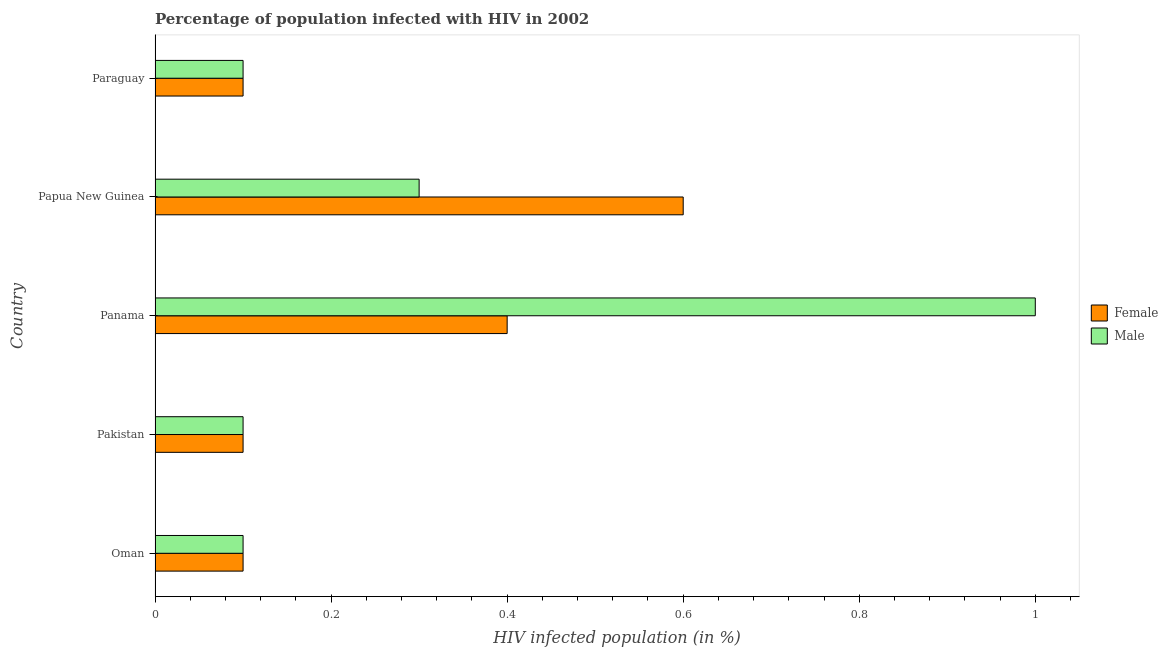What is the label of the 3rd group of bars from the top?
Offer a very short reply. Panama. In how many cases, is the number of bars for a given country not equal to the number of legend labels?
Give a very brief answer. 0. What is the percentage of males who are infected with hiv in Panama?
Offer a terse response. 1. Across all countries, what is the minimum percentage of males who are infected with hiv?
Provide a short and direct response. 0.1. In which country was the percentage of males who are infected with hiv maximum?
Keep it short and to the point. Panama. In which country was the percentage of males who are infected with hiv minimum?
Offer a very short reply. Oman. What is the total percentage of females who are infected with hiv in the graph?
Make the answer very short. 1.3. What is the average percentage of males who are infected with hiv per country?
Give a very brief answer. 0.32. Is the difference between the percentage of females who are infected with hiv in Papua New Guinea and Paraguay greater than the difference between the percentage of males who are infected with hiv in Papua New Guinea and Paraguay?
Provide a short and direct response. Yes. What is the difference between the highest and the second highest percentage of males who are infected with hiv?
Your answer should be very brief. 0.7. Is the sum of the percentage of females who are infected with hiv in Oman and Panama greater than the maximum percentage of males who are infected with hiv across all countries?
Provide a succinct answer. No. How many bars are there?
Offer a very short reply. 10. Are all the bars in the graph horizontal?
Give a very brief answer. Yes. Are the values on the major ticks of X-axis written in scientific E-notation?
Your answer should be very brief. No. How many legend labels are there?
Make the answer very short. 2. What is the title of the graph?
Provide a short and direct response. Percentage of population infected with HIV in 2002. What is the label or title of the X-axis?
Your response must be concise. HIV infected population (in %). What is the HIV infected population (in %) in Male in Oman?
Make the answer very short. 0.1. What is the HIV infected population (in %) in Male in Pakistan?
Make the answer very short. 0.1. What is the HIV infected population (in %) in Female in Panama?
Keep it short and to the point. 0.4. What is the HIV infected population (in %) in Male in Papua New Guinea?
Provide a succinct answer. 0.3. Across all countries, what is the maximum HIV infected population (in %) of Female?
Your response must be concise. 0.6. Across all countries, what is the maximum HIV infected population (in %) in Male?
Offer a very short reply. 1. Across all countries, what is the minimum HIV infected population (in %) in Female?
Your answer should be compact. 0.1. What is the total HIV infected population (in %) in Female in the graph?
Ensure brevity in your answer.  1.3. What is the difference between the HIV infected population (in %) in Male in Oman and that in Pakistan?
Offer a very short reply. 0. What is the difference between the HIV infected population (in %) of Male in Oman and that in Panama?
Your response must be concise. -0.9. What is the difference between the HIV infected population (in %) of Female in Oman and that in Paraguay?
Offer a very short reply. 0. What is the difference between the HIV infected population (in %) of Male in Pakistan and that in Papua New Guinea?
Offer a very short reply. -0.2. What is the difference between the HIV infected population (in %) of Female in Oman and the HIV infected population (in %) of Male in Pakistan?
Ensure brevity in your answer.  0. What is the difference between the HIV infected population (in %) of Female in Oman and the HIV infected population (in %) of Male in Panama?
Give a very brief answer. -0.9. What is the difference between the HIV infected population (in %) of Female in Pakistan and the HIV infected population (in %) of Male in Papua New Guinea?
Ensure brevity in your answer.  -0.2. What is the difference between the HIV infected population (in %) of Female in Papua New Guinea and the HIV infected population (in %) of Male in Paraguay?
Provide a short and direct response. 0.5. What is the average HIV infected population (in %) of Female per country?
Your answer should be compact. 0.26. What is the average HIV infected population (in %) of Male per country?
Your answer should be compact. 0.32. What is the difference between the HIV infected population (in %) of Female and HIV infected population (in %) of Male in Oman?
Ensure brevity in your answer.  0. What is the difference between the HIV infected population (in %) of Female and HIV infected population (in %) of Male in Panama?
Offer a very short reply. -0.6. What is the difference between the HIV infected population (in %) in Female and HIV infected population (in %) in Male in Papua New Guinea?
Offer a terse response. 0.3. What is the ratio of the HIV infected population (in %) in Female in Oman to that in Pakistan?
Your response must be concise. 1. What is the ratio of the HIV infected population (in %) of Female in Oman to that in Panama?
Provide a succinct answer. 0.25. What is the ratio of the HIV infected population (in %) of Male in Oman to that in Panama?
Keep it short and to the point. 0.1. What is the ratio of the HIV infected population (in %) in Female in Oman to that in Paraguay?
Make the answer very short. 1. What is the ratio of the HIV infected population (in %) in Male in Pakistan to that in Panama?
Make the answer very short. 0.1. What is the ratio of the HIV infected population (in %) in Female in Pakistan to that in Papua New Guinea?
Provide a short and direct response. 0.17. What is the ratio of the HIV infected population (in %) of Female in Pakistan to that in Paraguay?
Make the answer very short. 1. What is the ratio of the HIV infected population (in %) in Male in Pakistan to that in Paraguay?
Give a very brief answer. 1. What is the ratio of the HIV infected population (in %) of Male in Panama to that in Papua New Guinea?
Offer a very short reply. 3.33. What is the ratio of the HIV infected population (in %) of Male in Panama to that in Paraguay?
Give a very brief answer. 10. What is the ratio of the HIV infected population (in %) in Male in Papua New Guinea to that in Paraguay?
Your answer should be compact. 3. What is the difference between the highest and the second highest HIV infected population (in %) of Female?
Make the answer very short. 0.2. What is the difference between the highest and the second highest HIV infected population (in %) of Male?
Make the answer very short. 0.7. What is the difference between the highest and the lowest HIV infected population (in %) of Female?
Your answer should be very brief. 0.5. What is the difference between the highest and the lowest HIV infected population (in %) in Male?
Ensure brevity in your answer.  0.9. 